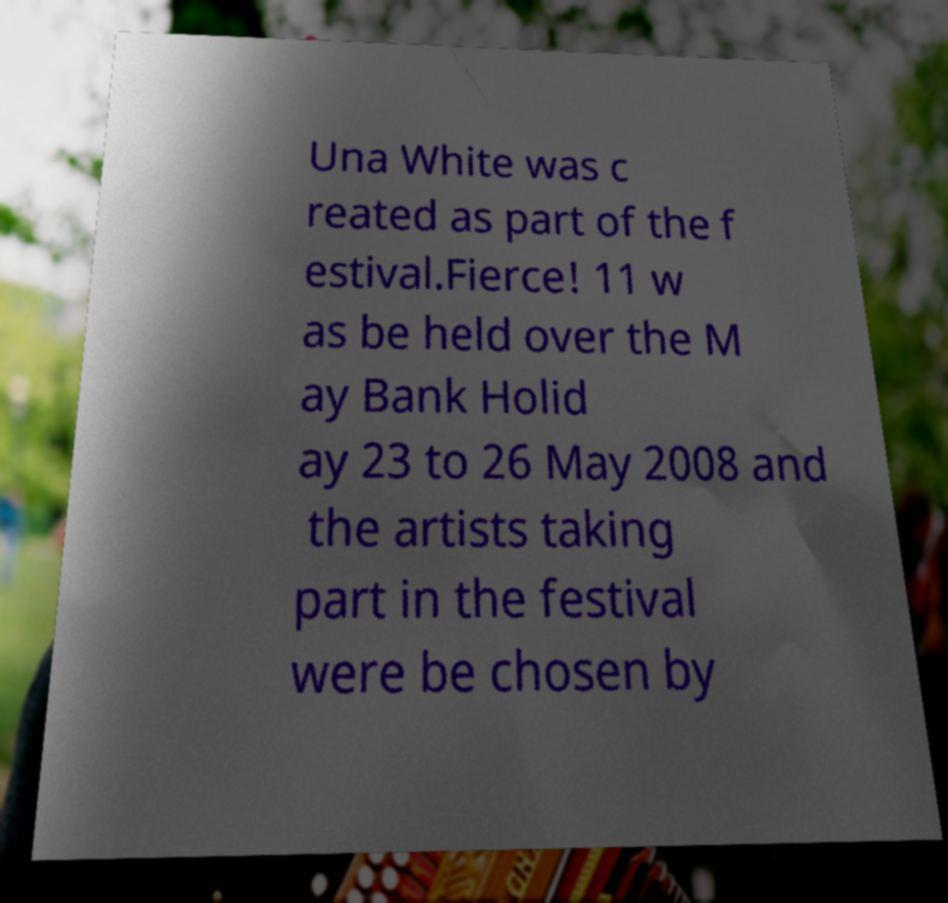Could you assist in decoding the text presented in this image and type it out clearly? Una White was c reated as part of the f estival.Fierce! 11 w as be held over the M ay Bank Holid ay 23 to 26 May 2008 and the artists taking part in the festival were be chosen by 